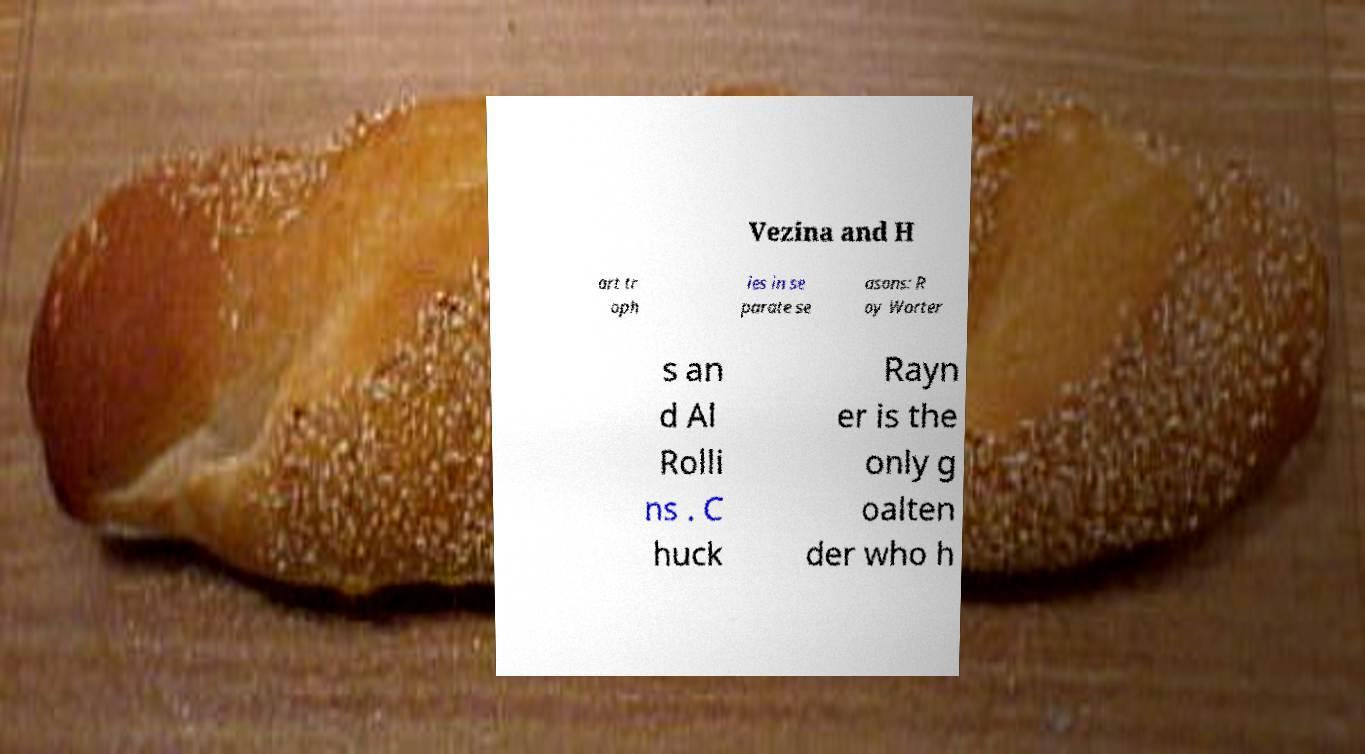For documentation purposes, I need the text within this image transcribed. Could you provide that? Vezina and H art tr oph ies in se parate se asons: R oy Worter s an d Al Rolli ns . C huck Rayn er is the only g oalten der who h 